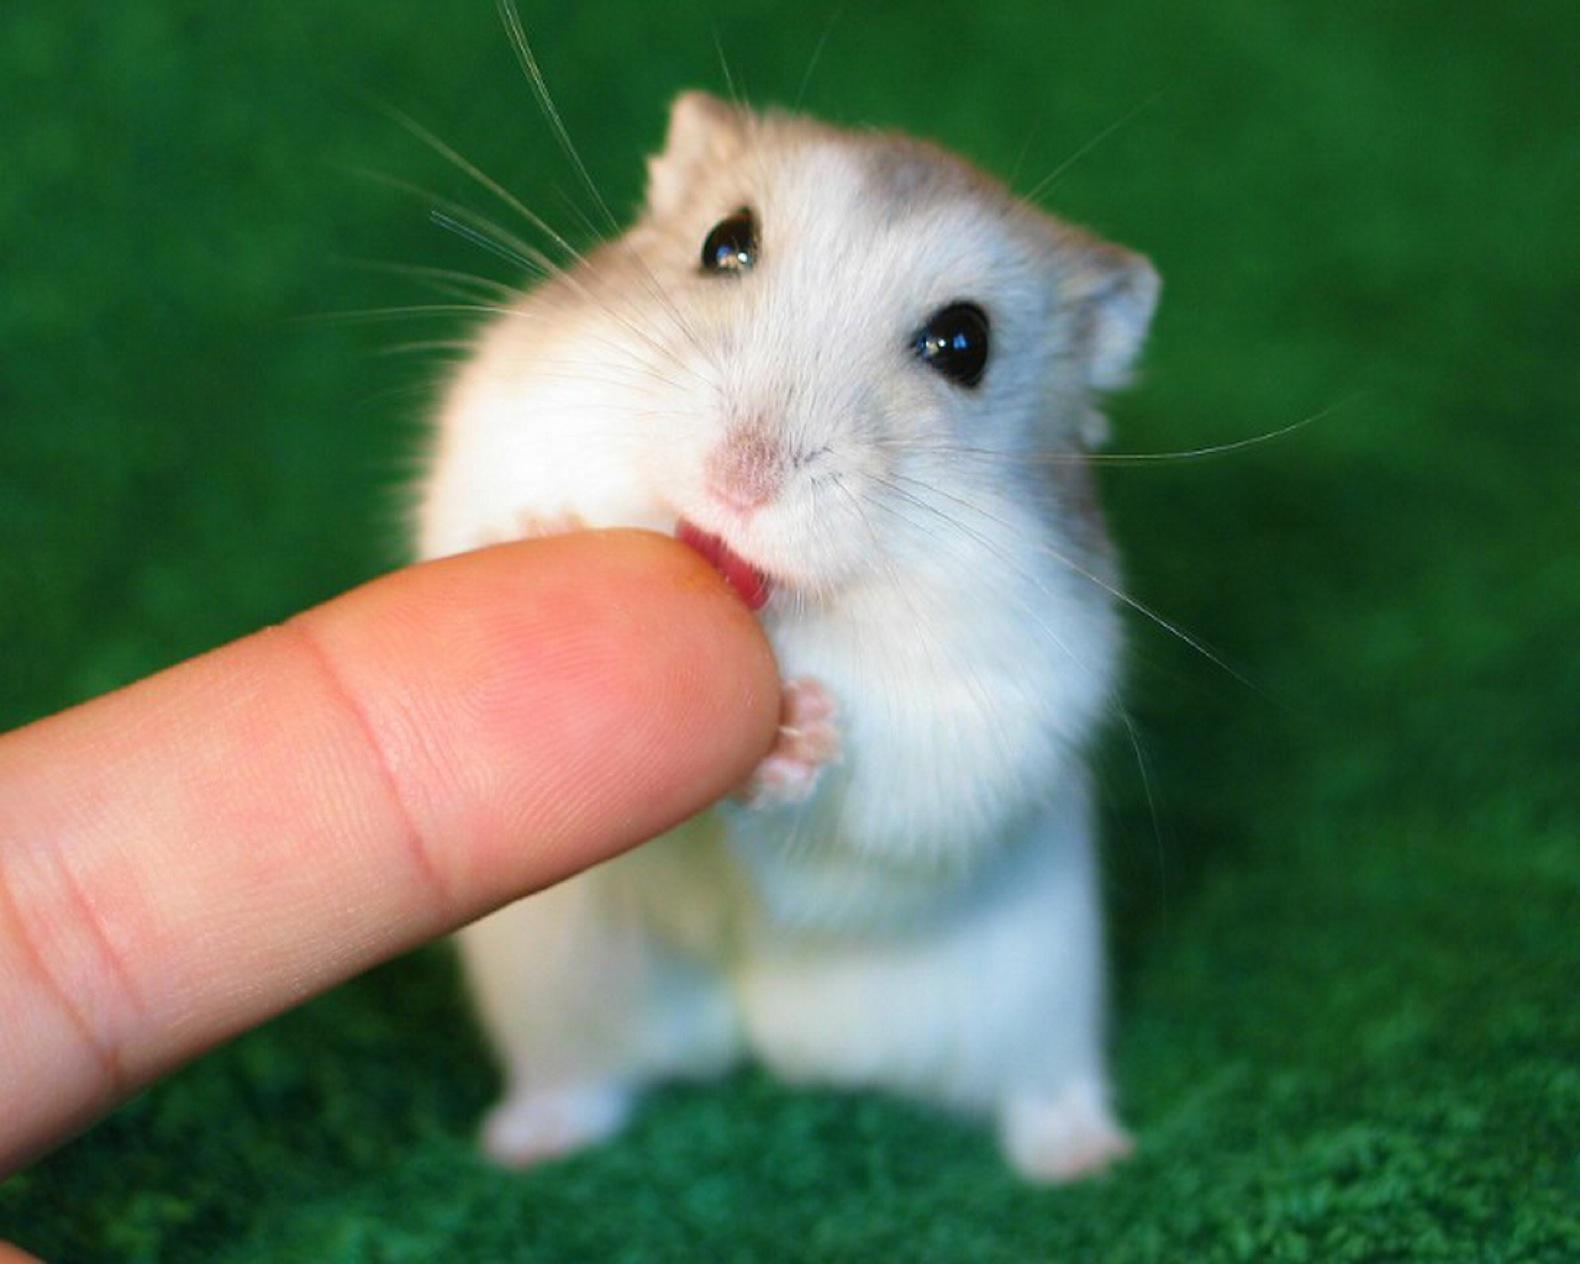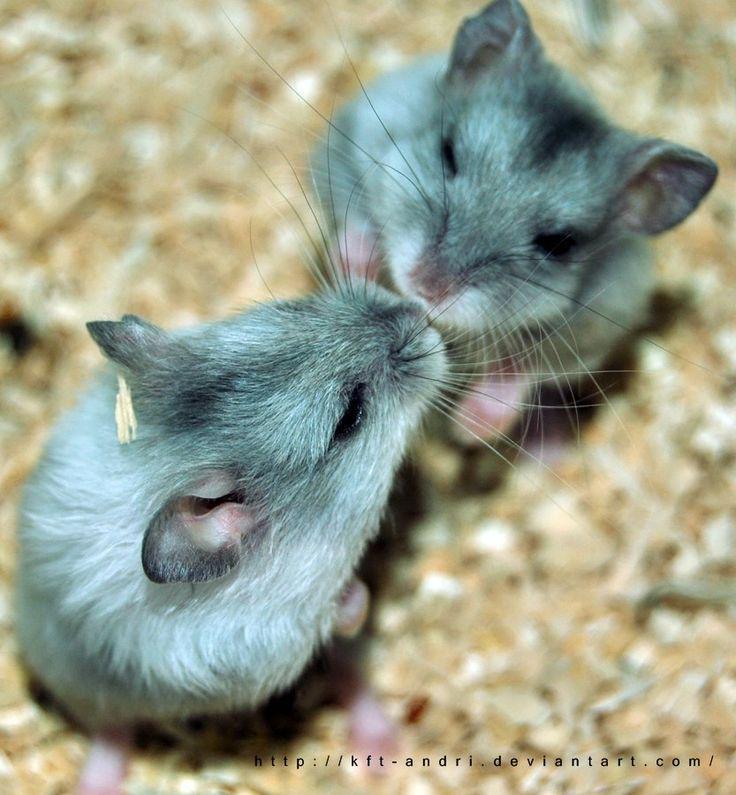The first image is the image on the left, the second image is the image on the right. Analyze the images presented: Is the assertion "One of the images clearly shows a hamster's tongue licking someone's finger." valid? Answer yes or no. Yes. The first image is the image on the left, the second image is the image on the right. Evaluate the accuracy of this statement regarding the images: "Has atleast one picture of an animal licking a finger". Is it true? Answer yes or no. Yes. 